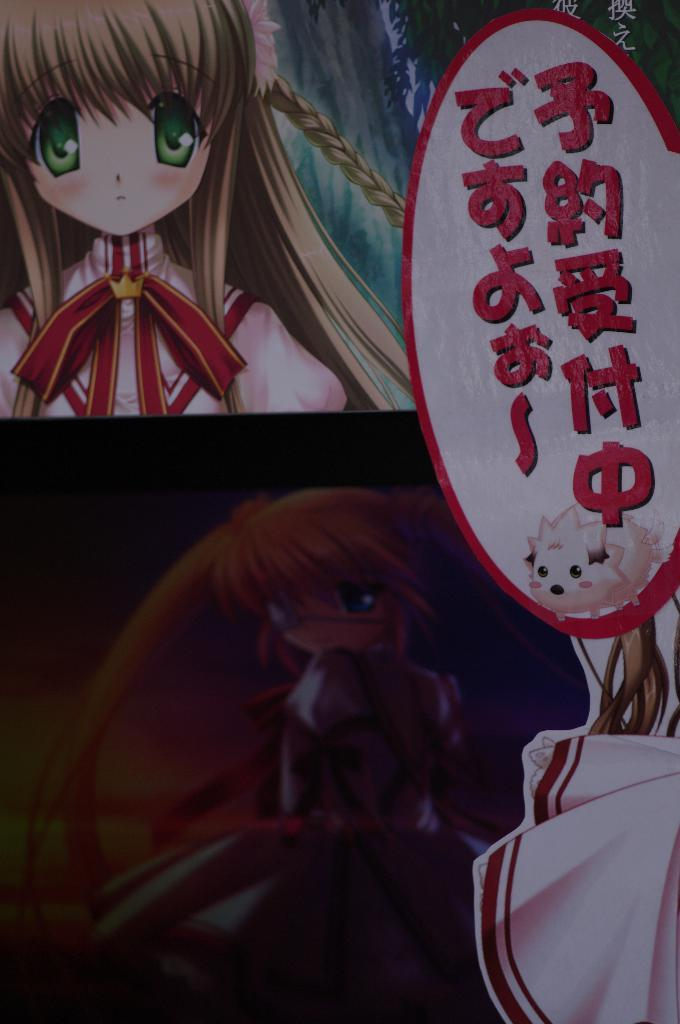What type of characters are present in the image? There are animated girls in the image. What else can be seen in the image besides the animated girls? There is some text on the image. Where is the throne located in the image? There is no throne present in the image. What type of bird can be seen perched on the animated girls' heads in the image? There are no birds present in the image. What type of food is visible in the image? There is no food visible in the image. 